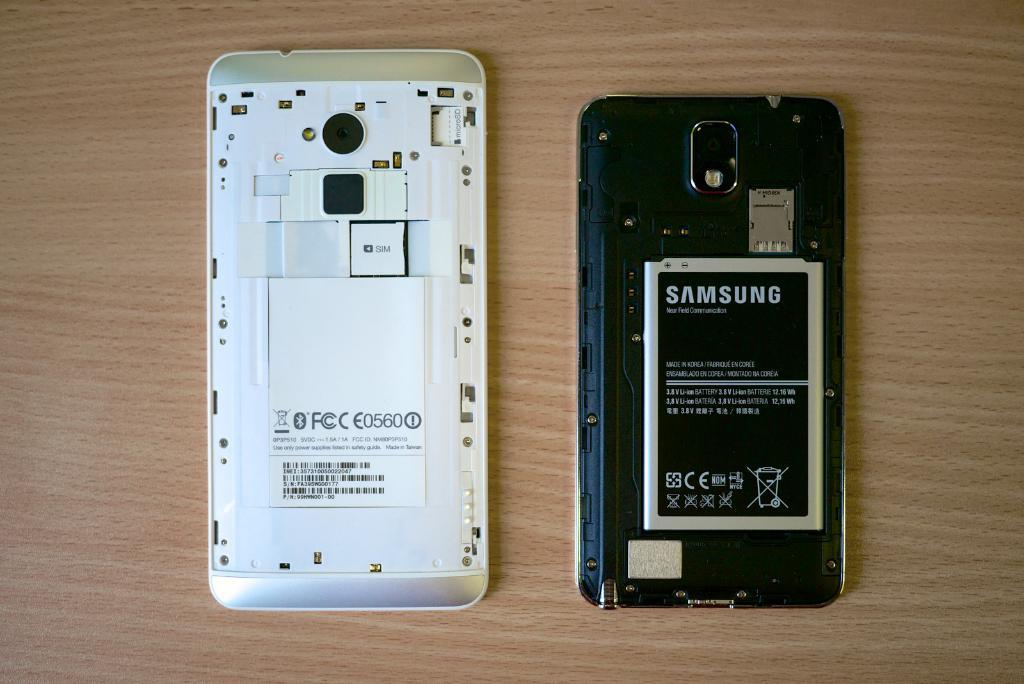How many mobiles are visible in the image? There are two mobiles in the image. What powers the mobiles in the image? The mobiles have batteries. Where are the mobiles and batteries located in the image? The mobiles and batteries are on a table. How does the uncle use the swing in the image? There is no uncle or swing present in the image. 